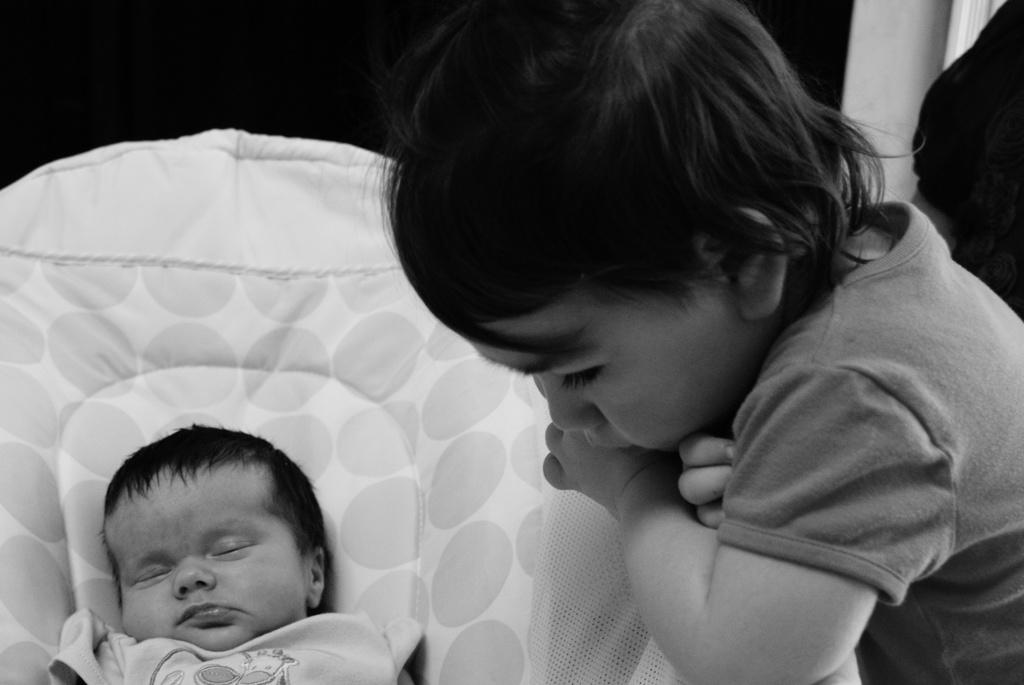What is the color scheme of the image? The image is black and white. Who is present in the image? There is a girl in the image. What is the girl doing in the image? The girl is standing beside a baby. What type of branch is the girl holding in the image? There is no branch present in the image; the girl is standing beside a baby. How many masses can be seen in the image? There is no reference to mass in the image; it features a girl standing beside a baby. 